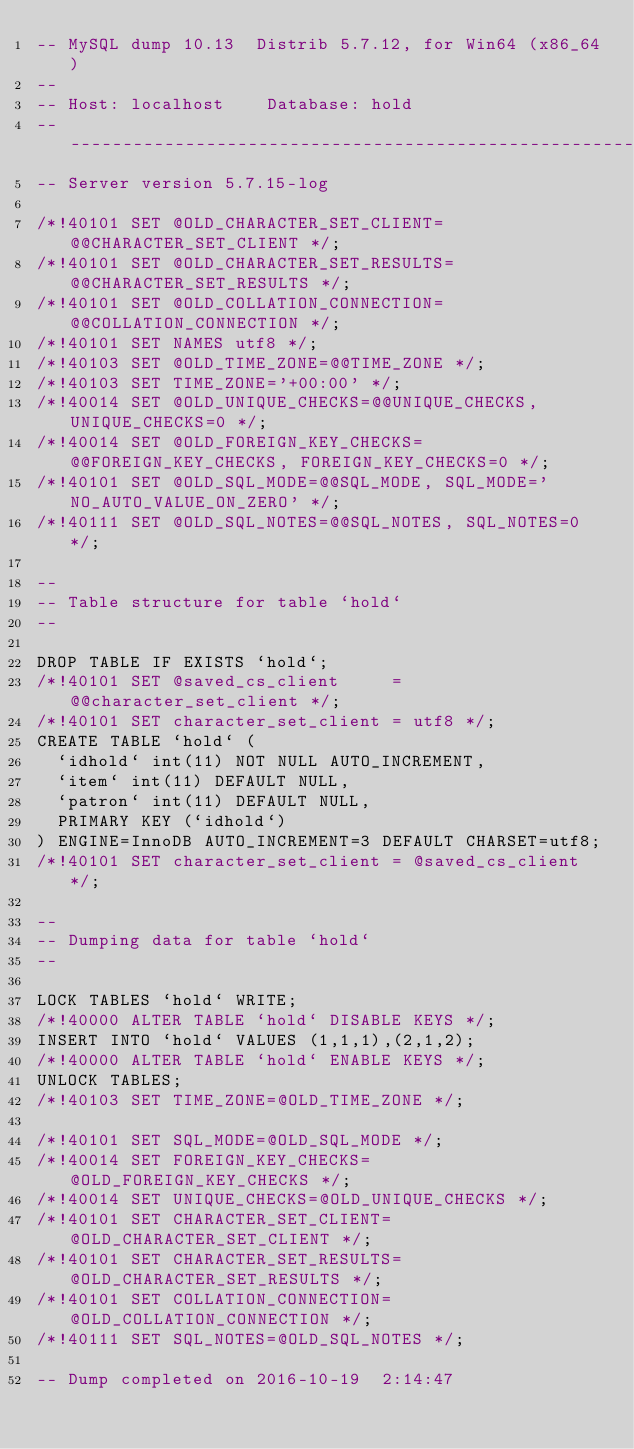Convert code to text. <code><loc_0><loc_0><loc_500><loc_500><_SQL_>-- MySQL dump 10.13  Distrib 5.7.12, for Win64 (x86_64)
--
-- Host: localhost    Database: hold
-- ------------------------------------------------------
-- Server version	5.7.15-log

/*!40101 SET @OLD_CHARACTER_SET_CLIENT=@@CHARACTER_SET_CLIENT */;
/*!40101 SET @OLD_CHARACTER_SET_RESULTS=@@CHARACTER_SET_RESULTS */;
/*!40101 SET @OLD_COLLATION_CONNECTION=@@COLLATION_CONNECTION */;
/*!40101 SET NAMES utf8 */;
/*!40103 SET @OLD_TIME_ZONE=@@TIME_ZONE */;
/*!40103 SET TIME_ZONE='+00:00' */;
/*!40014 SET @OLD_UNIQUE_CHECKS=@@UNIQUE_CHECKS, UNIQUE_CHECKS=0 */;
/*!40014 SET @OLD_FOREIGN_KEY_CHECKS=@@FOREIGN_KEY_CHECKS, FOREIGN_KEY_CHECKS=0 */;
/*!40101 SET @OLD_SQL_MODE=@@SQL_MODE, SQL_MODE='NO_AUTO_VALUE_ON_ZERO' */;
/*!40111 SET @OLD_SQL_NOTES=@@SQL_NOTES, SQL_NOTES=0 */;

--
-- Table structure for table `hold`
--

DROP TABLE IF EXISTS `hold`;
/*!40101 SET @saved_cs_client     = @@character_set_client */;
/*!40101 SET character_set_client = utf8 */;
CREATE TABLE `hold` (
  `idhold` int(11) NOT NULL AUTO_INCREMENT,
  `item` int(11) DEFAULT NULL,
  `patron` int(11) DEFAULT NULL,
  PRIMARY KEY (`idhold`)
) ENGINE=InnoDB AUTO_INCREMENT=3 DEFAULT CHARSET=utf8;
/*!40101 SET character_set_client = @saved_cs_client */;

--
-- Dumping data for table `hold`
--

LOCK TABLES `hold` WRITE;
/*!40000 ALTER TABLE `hold` DISABLE KEYS */;
INSERT INTO `hold` VALUES (1,1,1),(2,1,2);
/*!40000 ALTER TABLE `hold` ENABLE KEYS */;
UNLOCK TABLES;
/*!40103 SET TIME_ZONE=@OLD_TIME_ZONE */;

/*!40101 SET SQL_MODE=@OLD_SQL_MODE */;
/*!40014 SET FOREIGN_KEY_CHECKS=@OLD_FOREIGN_KEY_CHECKS */;
/*!40014 SET UNIQUE_CHECKS=@OLD_UNIQUE_CHECKS */;
/*!40101 SET CHARACTER_SET_CLIENT=@OLD_CHARACTER_SET_CLIENT */;
/*!40101 SET CHARACTER_SET_RESULTS=@OLD_CHARACTER_SET_RESULTS */;
/*!40101 SET COLLATION_CONNECTION=@OLD_COLLATION_CONNECTION */;
/*!40111 SET SQL_NOTES=@OLD_SQL_NOTES */;

-- Dump completed on 2016-10-19  2:14:47
</code> 